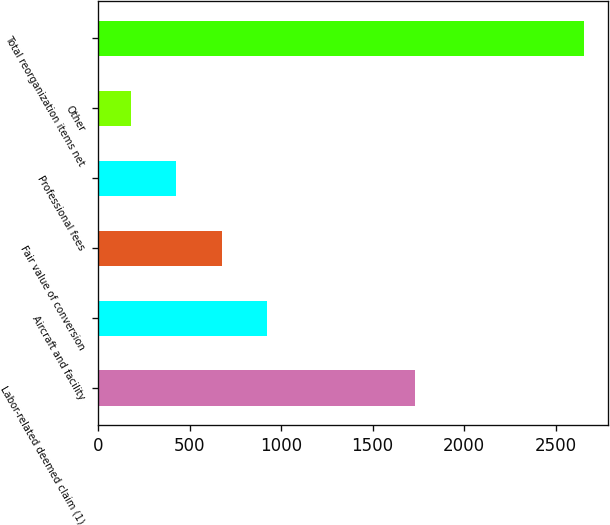Convert chart to OTSL. <chart><loc_0><loc_0><loc_500><loc_500><bar_chart><fcel>Labor-related deemed claim (1)<fcel>Aircraft and facility<fcel>Fair value of conversion<fcel>Professional fees<fcel>Other<fcel>Total reorganization items net<nl><fcel>1733<fcel>922.5<fcel>675<fcel>427.5<fcel>180<fcel>2655<nl></chart> 